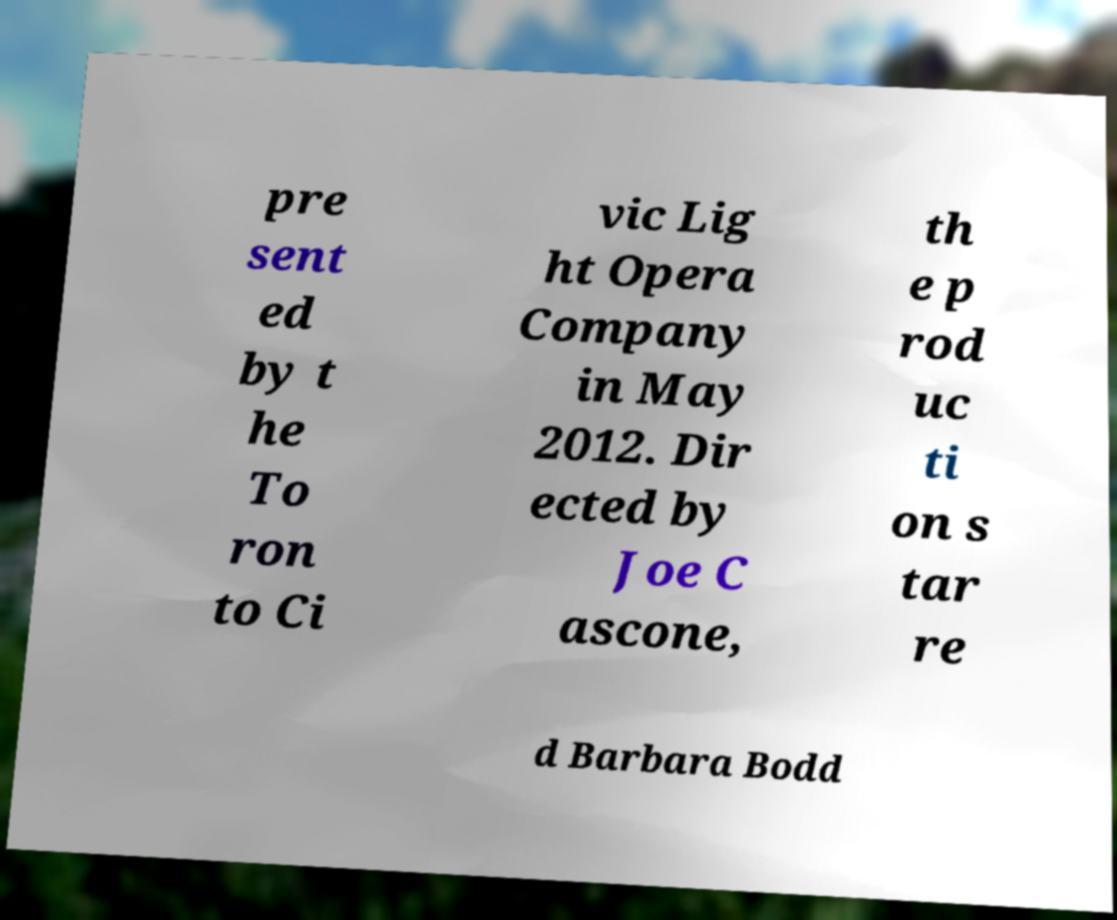Could you assist in decoding the text presented in this image and type it out clearly? pre sent ed by t he To ron to Ci vic Lig ht Opera Company in May 2012. Dir ected by Joe C ascone, th e p rod uc ti on s tar re d Barbara Bodd 